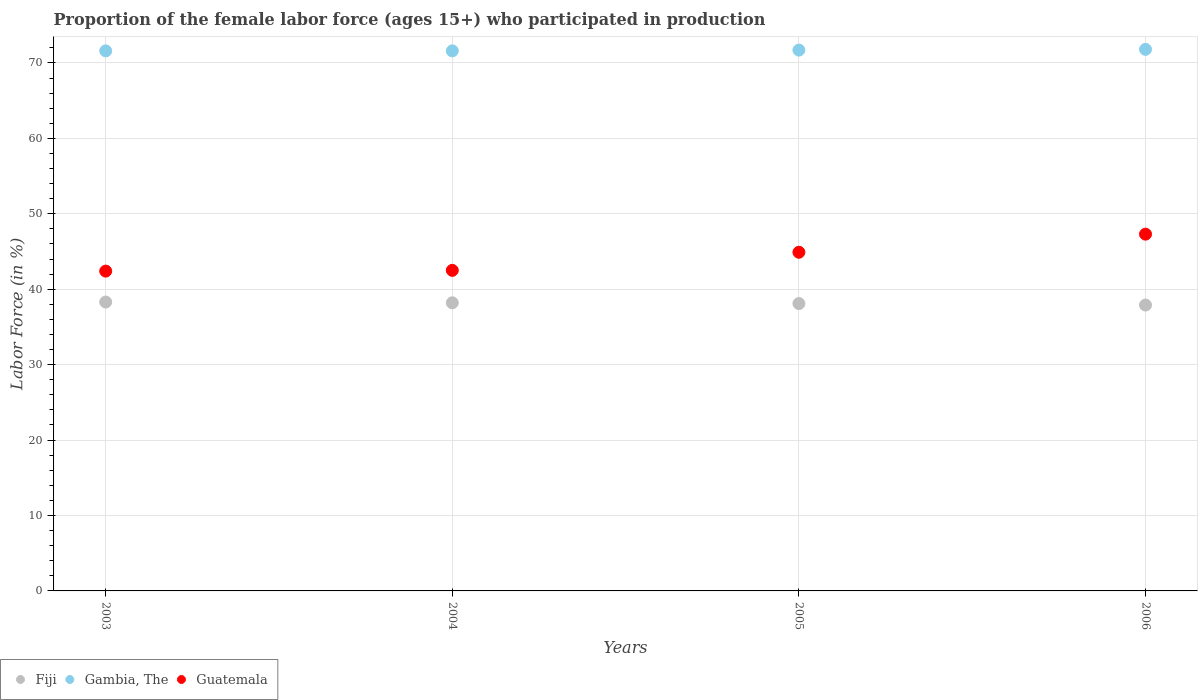How many different coloured dotlines are there?
Make the answer very short. 3. What is the proportion of the female labor force who participated in production in Fiji in 2004?
Your answer should be very brief. 38.2. Across all years, what is the maximum proportion of the female labor force who participated in production in Fiji?
Offer a very short reply. 38.3. Across all years, what is the minimum proportion of the female labor force who participated in production in Gambia, The?
Keep it short and to the point. 71.6. In which year was the proportion of the female labor force who participated in production in Guatemala maximum?
Ensure brevity in your answer.  2006. What is the total proportion of the female labor force who participated in production in Guatemala in the graph?
Give a very brief answer. 177.1. What is the difference between the proportion of the female labor force who participated in production in Fiji in 2005 and that in 2006?
Provide a short and direct response. 0.2. What is the difference between the proportion of the female labor force who participated in production in Guatemala in 2003 and the proportion of the female labor force who participated in production in Fiji in 2005?
Offer a terse response. 4.3. What is the average proportion of the female labor force who participated in production in Fiji per year?
Make the answer very short. 38.12. In the year 2003, what is the difference between the proportion of the female labor force who participated in production in Guatemala and proportion of the female labor force who participated in production in Gambia, The?
Ensure brevity in your answer.  -29.2. In how many years, is the proportion of the female labor force who participated in production in Fiji greater than 38 %?
Ensure brevity in your answer.  3. What is the ratio of the proportion of the female labor force who participated in production in Gambia, The in 2005 to that in 2006?
Provide a succinct answer. 1. Is the proportion of the female labor force who participated in production in Fiji in 2005 less than that in 2006?
Your response must be concise. No. What is the difference between the highest and the second highest proportion of the female labor force who participated in production in Guatemala?
Your answer should be very brief. 2.4. What is the difference between the highest and the lowest proportion of the female labor force who participated in production in Guatemala?
Provide a succinct answer. 4.9. In how many years, is the proportion of the female labor force who participated in production in Fiji greater than the average proportion of the female labor force who participated in production in Fiji taken over all years?
Your answer should be very brief. 2. Is it the case that in every year, the sum of the proportion of the female labor force who participated in production in Gambia, The and proportion of the female labor force who participated in production in Guatemala  is greater than the proportion of the female labor force who participated in production in Fiji?
Provide a succinct answer. Yes. Does the proportion of the female labor force who participated in production in Fiji monotonically increase over the years?
Give a very brief answer. No. Is the proportion of the female labor force who participated in production in Guatemala strictly less than the proportion of the female labor force who participated in production in Gambia, The over the years?
Give a very brief answer. Yes. How many dotlines are there?
Make the answer very short. 3. What is the difference between two consecutive major ticks on the Y-axis?
Give a very brief answer. 10. Where does the legend appear in the graph?
Your response must be concise. Bottom left. What is the title of the graph?
Give a very brief answer. Proportion of the female labor force (ages 15+) who participated in production. Does "Saudi Arabia" appear as one of the legend labels in the graph?
Keep it short and to the point. No. What is the label or title of the X-axis?
Give a very brief answer. Years. What is the label or title of the Y-axis?
Provide a succinct answer. Labor Force (in %). What is the Labor Force (in %) of Fiji in 2003?
Make the answer very short. 38.3. What is the Labor Force (in %) of Gambia, The in 2003?
Your answer should be compact. 71.6. What is the Labor Force (in %) in Guatemala in 2003?
Provide a succinct answer. 42.4. What is the Labor Force (in %) in Fiji in 2004?
Ensure brevity in your answer.  38.2. What is the Labor Force (in %) of Gambia, The in 2004?
Keep it short and to the point. 71.6. What is the Labor Force (in %) of Guatemala in 2004?
Offer a very short reply. 42.5. What is the Labor Force (in %) in Fiji in 2005?
Ensure brevity in your answer.  38.1. What is the Labor Force (in %) of Gambia, The in 2005?
Give a very brief answer. 71.7. What is the Labor Force (in %) in Guatemala in 2005?
Keep it short and to the point. 44.9. What is the Labor Force (in %) of Fiji in 2006?
Your answer should be very brief. 37.9. What is the Labor Force (in %) in Gambia, The in 2006?
Provide a succinct answer. 71.8. What is the Labor Force (in %) in Guatemala in 2006?
Provide a short and direct response. 47.3. Across all years, what is the maximum Labor Force (in %) of Fiji?
Keep it short and to the point. 38.3. Across all years, what is the maximum Labor Force (in %) of Gambia, The?
Your answer should be very brief. 71.8. Across all years, what is the maximum Labor Force (in %) in Guatemala?
Offer a very short reply. 47.3. Across all years, what is the minimum Labor Force (in %) in Fiji?
Ensure brevity in your answer.  37.9. Across all years, what is the minimum Labor Force (in %) in Gambia, The?
Your answer should be very brief. 71.6. Across all years, what is the minimum Labor Force (in %) in Guatemala?
Your answer should be compact. 42.4. What is the total Labor Force (in %) in Fiji in the graph?
Offer a very short reply. 152.5. What is the total Labor Force (in %) of Gambia, The in the graph?
Ensure brevity in your answer.  286.7. What is the total Labor Force (in %) of Guatemala in the graph?
Your response must be concise. 177.1. What is the difference between the Labor Force (in %) of Fiji in 2003 and that in 2004?
Provide a succinct answer. 0.1. What is the difference between the Labor Force (in %) in Guatemala in 2003 and that in 2004?
Provide a short and direct response. -0.1. What is the difference between the Labor Force (in %) in Fiji in 2003 and that in 2005?
Give a very brief answer. 0.2. What is the difference between the Labor Force (in %) in Guatemala in 2003 and that in 2005?
Your answer should be compact. -2.5. What is the difference between the Labor Force (in %) in Gambia, The in 2003 and that in 2006?
Provide a succinct answer. -0.2. What is the difference between the Labor Force (in %) of Guatemala in 2004 and that in 2005?
Offer a terse response. -2.4. What is the difference between the Labor Force (in %) of Gambia, The in 2005 and that in 2006?
Offer a very short reply. -0.1. What is the difference between the Labor Force (in %) in Fiji in 2003 and the Labor Force (in %) in Gambia, The in 2004?
Give a very brief answer. -33.3. What is the difference between the Labor Force (in %) in Gambia, The in 2003 and the Labor Force (in %) in Guatemala in 2004?
Your answer should be very brief. 29.1. What is the difference between the Labor Force (in %) in Fiji in 2003 and the Labor Force (in %) in Gambia, The in 2005?
Your response must be concise. -33.4. What is the difference between the Labor Force (in %) in Fiji in 2003 and the Labor Force (in %) in Guatemala in 2005?
Provide a short and direct response. -6.6. What is the difference between the Labor Force (in %) in Gambia, The in 2003 and the Labor Force (in %) in Guatemala in 2005?
Your answer should be compact. 26.7. What is the difference between the Labor Force (in %) of Fiji in 2003 and the Labor Force (in %) of Gambia, The in 2006?
Your answer should be very brief. -33.5. What is the difference between the Labor Force (in %) in Gambia, The in 2003 and the Labor Force (in %) in Guatemala in 2006?
Make the answer very short. 24.3. What is the difference between the Labor Force (in %) in Fiji in 2004 and the Labor Force (in %) in Gambia, The in 2005?
Your response must be concise. -33.5. What is the difference between the Labor Force (in %) of Fiji in 2004 and the Labor Force (in %) of Guatemala in 2005?
Your answer should be very brief. -6.7. What is the difference between the Labor Force (in %) in Gambia, The in 2004 and the Labor Force (in %) in Guatemala in 2005?
Keep it short and to the point. 26.7. What is the difference between the Labor Force (in %) in Fiji in 2004 and the Labor Force (in %) in Gambia, The in 2006?
Keep it short and to the point. -33.6. What is the difference between the Labor Force (in %) in Gambia, The in 2004 and the Labor Force (in %) in Guatemala in 2006?
Make the answer very short. 24.3. What is the difference between the Labor Force (in %) of Fiji in 2005 and the Labor Force (in %) of Gambia, The in 2006?
Ensure brevity in your answer.  -33.7. What is the difference between the Labor Force (in %) of Fiji in 2005 and the Labor Force (in %) of Guatemala in 2006?
Keep it short and to the point. -9.2. What is the difference between the Labor Force (in %) of Gambia, The in 2005 and the Labor Force (in %) of Guatemala in 2006?
Ensure brevity in your answer.  24.4. What is the average Labor Force (in %) of Fiji per year?
Give a very brief answer. 38.12. What is the average Labor Force (in %) in Gambia, The per year?
Your answer should be compact. 71.67. What is the average Labor Force (in %) of Guatemala per year?
Offer a very short reply. 44.27. In the year 2003, what is the difference between the Labor Force (in %) in Fiji and Labor Force (in %) in Gambia, The?
Offer a terse response. -33.3. In the year 2003, what is the difference between the Labor Force (in %) in Gambia, The and Labor Force (in %) in Guatemala?
Offer a very short reply. 29.2. In the year 2004, what is the difference between the Labor Force (in %) in Fiji and Labor Force (in %) in Gambia, The?
Your response must be concise. -33.4. In the year 2004, what is the difference between the Labor Force (in %) of Gambia, The and Labor Force (in %) of Guatemala?
Ensure brevity in your answer.  29.1. In the year 2005, what is the difference between the Labor Force (in %) of Fiji and Labor Force (in %) of Gambia, The?
Provide a succinct answer. -33.6. In the year 2005, what is the difference between the Labor Force (in %) in Gambia, The and Labor Force (in %) in Guatemala?
Your answer should be compact. 26.8. In the year 2006, what is the difference between the Labor Force (in %) in Fiji and Labor Force (in %) in Gambia, The?
Offer a very short reply. -33.9. In the year 2006, what is the difference between the Labor Force (in %) in Fiji and Labor Force (in %) in Guatemala?
Your response must be concise. -9.4. What is the ratio of the Labor Force (in %) in Fiji in 2003 to that in 2004?
Offer a terse response. 1. What is the ratio of the Labor Force (in %) in Gambia, The in 2003 to that in 2004?
Give a very brief answer. 1. What is the ratio of the Labor Force (in %) in Fiji in 2003 to that in 2005?
Your answer should be compact. 1.01. What is the ratio of the Labor Force (in %) of Guatemala in 2003 to that in 2005?
Your response must be concise. 0.94. What is the ratio of the Labor Force (in %) in Fiji in 2003 to that in 2006?
Provide a short and direct response. 1.01. What is the ratio of the Labor Force (in %) of Guatemala in 2003 to that in 2006?
Provide a short and direct response. 0.9. What is the ratio of the Labor Force (in %) in Guatemala in 2004 to that in 2005?
Ensure brevity in your answer.  0.95. What is the ratio of the Labor Force (in %) of Fiji in 2004 to that in 2006?
Your response must be concise. 1.01. What is the ratio of the Labor Force (in %) of Gambia, The in 2004 to that in 2006?
Your response must be concise. 1. What is the ratio of the Labor Force (in %) of Guatemala in 2004 to that in 2006?
Offer a terse response. 0.9. What is the ratio of the Labor Force (in %) of Guatemala in 2005 to that in 2006?
Your answer should be compact. 0.95. What is the difference between the highest and the lowest Labor Force (in %) in Guatemala?
Your answer should be very brief. 4.9. 